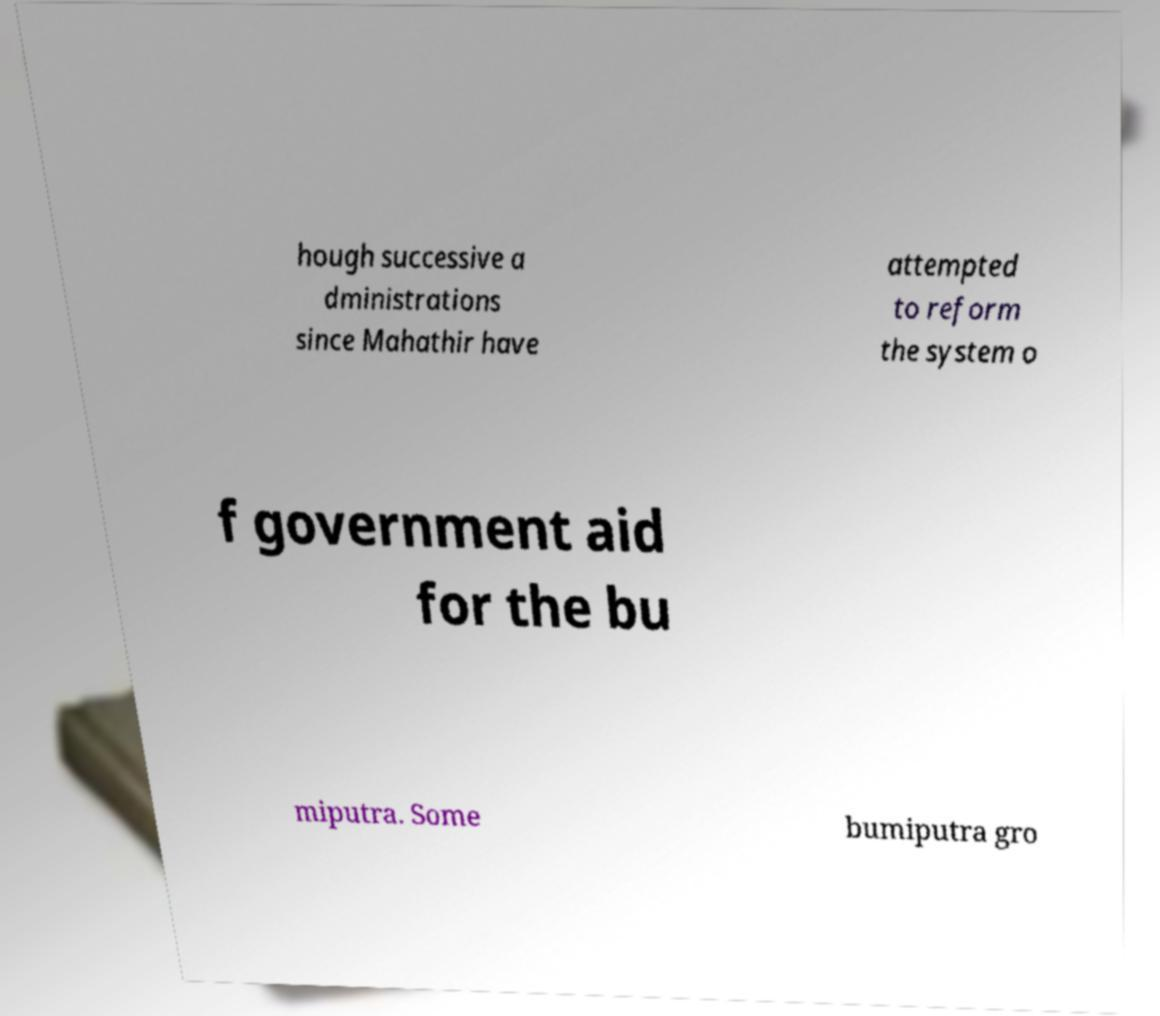Can you read and provide the text displayed in the image?This photo seems to have some interesting text. Can you extract and type it out for me? hough successive a dministrations since Mahathir have attempted to reform the system o f government aid for the bu miputra. Some bumiputra gro 